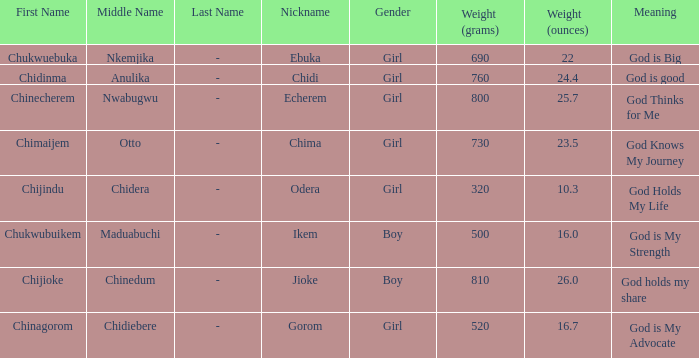What nickname has the meaning of God knows my journey? Chima. 